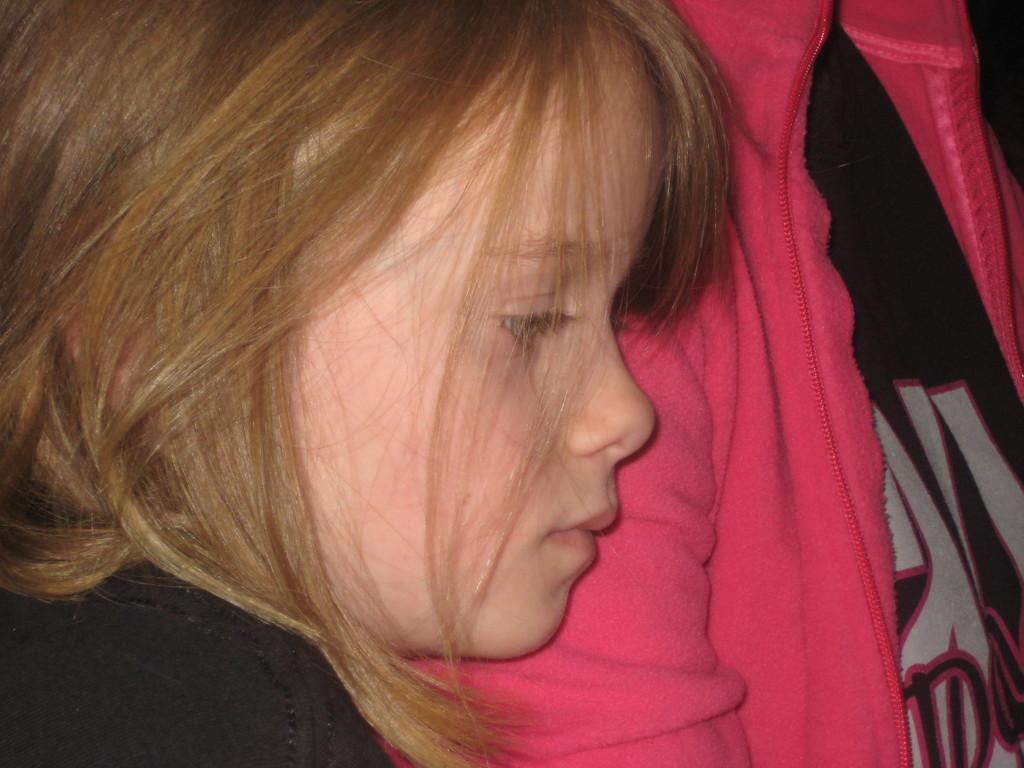How would you summarize this image in a sentence or two? Here in this picture we can see a child and a person present over a place. 